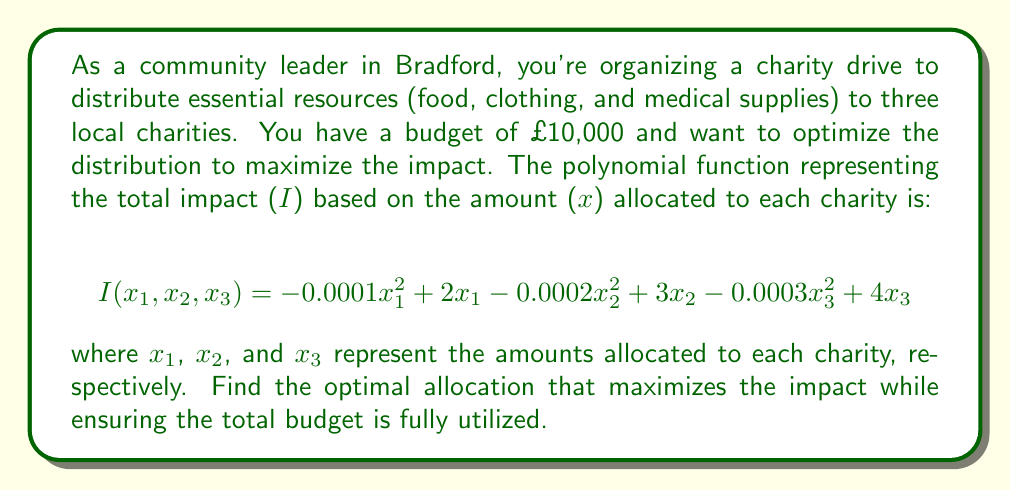What is the answer to this math problem? To solve this optimization problem, we need to use the method of Lagrange multipliers, as we have a constraint (total budget) along with our objective function.

Step 1: Set up the Lagrangian function
$$L(x_1, x_2, x_3, \lambda) = I(x_1, x_2, x_3) - \lambda(x_1 + x_2 + x_3 - 10000)$$

Step 2: Take partial derivatives and set them equal to zero
$$\frac{\partial L}{\partial x_1} = -0.0002x_1 + 2 - \lambda = 0$$
$$\frac{\partial L}{\partial x_2} = -0.0004x_2 + 3 - \lambda = 0$$
$$\frac{\partial L}{\partial x_3} = -0.0006x_3 + 4 - \lambda = 0$$
$$\frac{\partial L}{\partial \lambda} = x_1 + x_2 + x_3 - 10000 = 0$$

Step 3: Solve the system of equations
From the first three equations:
$$x_1 = 10000 - 5000\lambda$$
$$x_2 = 7500 - 2500\lambda$$
$$x_3 = 6666.67 - 1666.67\lambda$$

Substitute these into the fourth equation:
$$(10000 - 5000\lambda) + (7500 - 2500\lambda) + (6666.67 - 1666.67\lambda) = 10000$$
$$24166.67 - 9166.67\lambda = 10000$$
$$14166.67 = 9166.67\lambda$$
$$\lambda = 1.545$$

Step 4: Calculate the optimal allocations
$$x_1 = 10000 - 5000(1.545) = 2275$$
$$x_2 = 7500 - 2500(1.545) = 3637.5$$
$$x_3 = 6666.67 - 1666.67(1.545) = 4087.5$$

Step 5: Round to the nearest pound
$$x_1 = 2275$$
$$x_2 = 3638$$
$$x_3 = 4087$$

The total allocation is £10,000, which matches our budget constraint.
Answer: Charity 1: £2,275, Charity 2: £3,638, Charity 3: £4,087 